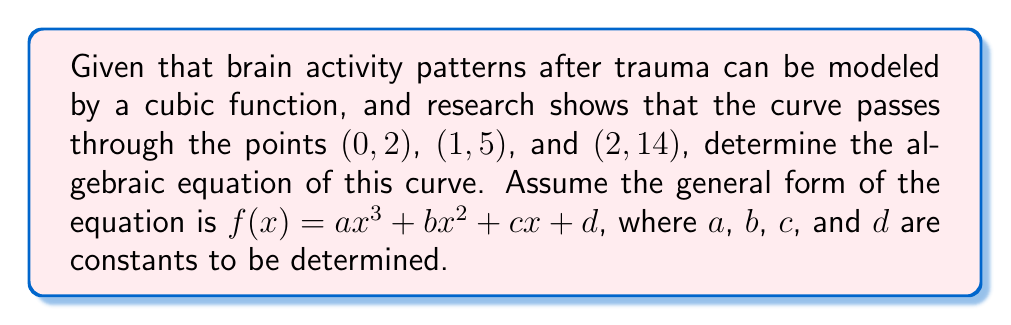Provide a solution to this math problem. Let's approach this step-by-step:

1) We have the general form: $f(x) = ax^3 + bx^2 + cx + d$

2) We know three points that the curve passes through:
   (0, 2), (1, 5), and (2, 14)

3) Let's substitute these points into our equation:

   For (0, 2): $2 = a(0)^3 + b(0)^2 + c(0) + d$
               $2 = d$

   For (1, 5): $5 = a(1)^3 + b(1)^2 + c(1) + d$
               $5 = a + b + c + 2$

   For (2, 14): $14 = a(2)^3 + b(2)^2 + c(2) + d$
                $14 = 8a + 4b + 2c + 2$

4) From the first equation, we know that $d = 2$

5) Substituting this into the other two equations:

   $3 = a + b + c$
   $12 = 8a + 4b + 2c$

6) Multiply the first equation by 2:

   $6 = 2a + 2b + 2c$
   $12 = 8a + 4b + 2c$

7) Subtract these equations:

   $6 = 6a + 2b$
   $3 = 3a + b$

8) Multiply the last equation by 2 and subtract:

   $0 = 0a + 0b$

This means we have infinite solutions. We need one more condition to solve this system uniquely.

9) Let's assume $a = 1$ (this is a common assumption for cubic functions)

10) Then from $3 = 3a + b$, we get:
    $3 = 3(1) + b$
    $b = 0$

11) And from $3 = a + b + c$, we get:
    $3 = 1 + 0 + c$
    $c = 2$

Therefore, the equation of the curve is:

$f(x) = x^3 + 2x + 2$
Answer: $f(x) = x^3 + 2x + 2$ 